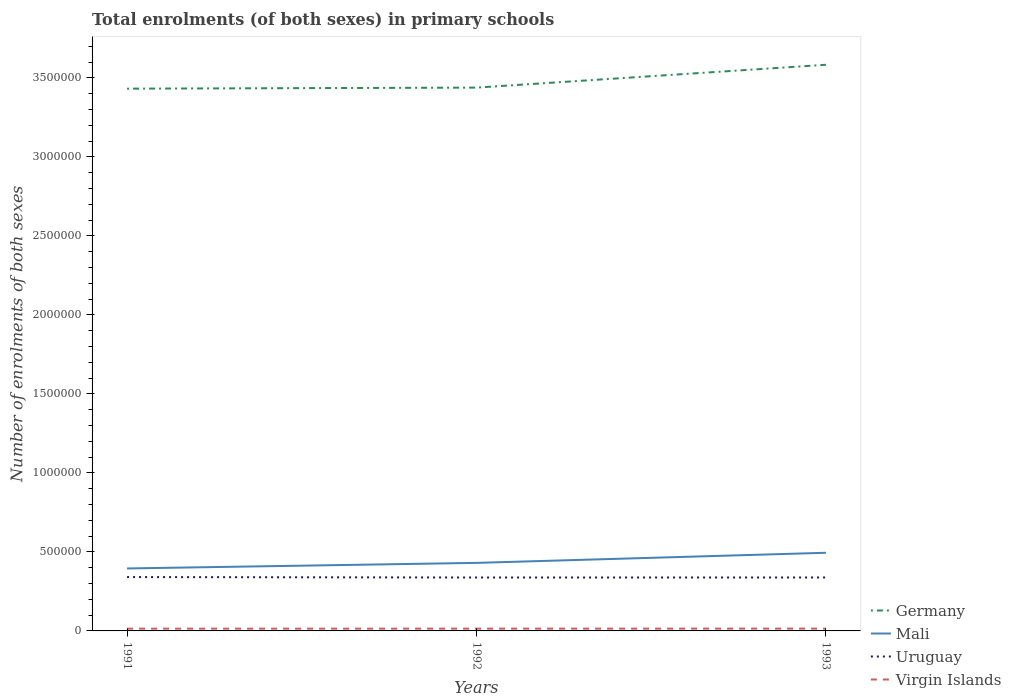Is the number of lines equal to the number of legend labels?
Offer a terse response. Yes. Across all years, what is the maximum number of enrolments in primary schools in Mali?
Give a very brief answer. 3.95e+05. In which year was the number of enrolments in primary schools in Germany maximum?
Offer a very short reply. 1991. What is the total number of enrolments in primary schools in Mali in the graph?
Give a very brief answer. -9.92e+04. What is the difference between the highest and the second highest number of enrolments in primary schools in Germany?
Ensure brevity in your answer.  1.51e+05. Is the number of enrolments in primary schools in Virgin Islands strictly greater than the number of enrolments in primary schools in Germany over the years?
Offer a terse response. Yes. How many lines are there?
Offer a terse response. 4. How many years are there in the graph?
Ensure brevity in your answer.  3. Does the graph contain any zero values?
Offer a very short reply. No. What is the title of the graph?
Your answer should be compact. Total enrolments (of both sexes) in primary schools. What is the label or title of the X-axis?
Provide a short and direct response. Years. What is the label or title of the Y-axis?
Offer a very short reply. Number of enrolments of both sexes. What is the Number of enrolments of both sexes in Germany in 1991?
Your response must be concise. 3.43e+06. What is the Number of enrolments of both sexes in Mali in 1991?
Your response must be concise. 3.95e+05. What is the Number of enrolments of both sexes of Uruguay in 1991?
Make the answer very short. 3.41e+05. What is the Number of enrolments of both sexes of Virgin Islands in 1991?
Offer a very short reply. 1.43e+04. What is the Number of enrolments of both sexes in Germany in 1992?
Offer a very short reply. 3.44e+06. What is the Number of enrolments of both sexes of Mali in 1992?
Give a very brief answer. 4.31e+05. What is the Number of enrolments of both sexes of Uruguay in 1992?
Keep it short and to the point. 3.38e+05. What is the Number of enrolments of both sexes of Virgin Islands in 1992?
Make the answer very short. 1.44e+04. What is the Number of enrolments of both sexes in Germany in 1993?
Ensure brevity in your answer.  3.58e+06. What is the Number of enrolments of both sexes in Mali in 1993?
Your answer should be very brief. 4.95e+05. What is the Number of enrolments of both sexes in Uruguay in 1993?
Give a very brief answer. 3.38e+05. What is the Number of enrolments of both sexes of Virgin Islands in 1993?
Make the answer very short. 1.45e+04. Across all years, what is the maximum Number of enrolments of both sexes of Germany?
Make the answer very short. 3.58e+06. Across all years, what is the maximum Number of enrolments of both sexes in Mali?
Your answer should be very brief. 4.95e+05. Across all years, what is the maximum Number of enrolments of both sexes of Uruguay?
Ensure brevity in your answer.  3.41e+05. Across all years, what is the maximum Number of enrolments of both sexes of Virgin Islands?
Your answer should be compact. 1.45e+04. Across all years, what is the minimum Number of enrolments of both sexes of Germany?
Offer a very short reply. 3.43e+06. Across all years, what is the minimum Number of enrolments of both sexes in Mali?
Your answer should be very brief. 3.95e+05. Across all years, what is the minimum Number of enrolments of both sexes of Uruguay?
Keep it short and to the point. 3.38e+05. Across all years, what is the minimum Number of enrolments of both sexes in Virgin Islands?
Offer a terse response. 1.43e+04. What is the total Number of enrolments of both sexes of Germany in the graph?
Make the answer very short. 1.05e+07. What is the total Number of enrolments of both sexes in Mali in the graph?
Offer a very short reply. 1.32e+06. What is the total Number of enrolments of both sexes of Uruguay in the graph?
Offer a terse response. 1.02e+06. What is the total Number of enrolments of both sexes in Virgin Islands in the graph?
Keep it short and to the point. 4.33e+04. What is the difference between the Number of enrolments of both sexes in Germany in 1991 and that in 1992?
Your answer should be compact. -6667. What is the difference between the Number of enrolments of both sexes of Mali in 1991 and that in 1992?
Provide a succinct answer. -3.53e+04. What is the difference between the Number of enrolments of both sexes of Uruguay in 1991 and that in 1992?
Provide a succinct answer. 2769. What is the difference between the Number of enrolments of both sexes in Virgin Islands in 1991 and that in 1992?
Keep it short and to the point. -81. What is the difference between the Number of enrolments of both sexes in Germany in 1991 and that in 1993?
Your response must be concise. -1.51e+05. What is the difference between the Number of enrolments of both sexes in Mali in 1991 and that in 1993?
Keep it short and to the point. -9.92e+04. What is the difference between the Number of enrolments of both sexes in Uruguay in 1991 and that in 1993?
Provide a succinct answer. 2585. What is the difference between the Number of enrolments of both sexes in Virgin Islands in 1991 and that in 1993?
Offer a terse response. -225. What is the difference between the Number of enrolments of both sexes of Germany in 1992 and that in 1993?
Your response must be concise. -1.45e+05. What is the difference between the Number of enrolments of both sexes in Mali in 1992 and that in 1993?
Keep it short and to the point. -6.39e+04. What is the difference between the Number of enrolments of both sexes of Uruguay in 1992 and that in 1993?
Offer a terse response. -184. What is the difference between the Number of enrolments of both sexes in Virgin Islands in 1992 and that in 1993?
Offer a very short reply. -144. What is the difference between the Number of enrolments of both sexes in Germany in 1991 and the Number of enrolments of both sexes in Mali in 1992?
Give a very brief answer. 3.00e+06. What is the difference between the Number of enrolments of both sexes in Germany in 1991 and the Number of enrolments of both sexes in Uruguay in 1992?
Your answer should be compact. 3.09e+06. What is the difference between the Number of enrolments of both sexes of Germany in 1991 and the Number of enrolments of both sexes of Virgin Islands in 1992?
Keep it short and to the point. 3.42e+06. What is the difference between the Number of enrolments of both sexes in Mali in 1991 and the Number of enrolments of both sexes in Uruguay in 1992?
Offer a terse response. 5.73e+04. What is the difference between the Number of enrolments of both sexes in Mali in 1991 and the Number of enrolments of both sexes in Virgin Islands in 1992?
Make the answer very short. 3.81e+05. What is the difference between the Number of enrolments of both sexes of Uruguay in 1991 and the Number of enrolments of both sexes of Virgin Islands in 1992?
Provide a succinct answer. 3.26e+05. What is the difference between the Number of enrolments of both sexes of Germany in 1991 and the Number of enrolments of both sexes of Mali in 1993?
Provide a succinct answer. 2.94e+06. What is the difference between the Number of enrolments of both sexes of Germany in 1991 and the Number of enrolments of both sexes of Uruguay in 1993?
Your response must be concise. 3.09e+06. What is the difference between the Number of enrolments of both sexes in Germany in 1991 and the Number of enrolments of both sexes in Virgin Islands in 1993?
Provide a short and direct response. 3.42e+06. What is the difference between the Number of enrolments of both sexes of Mali in 1991 and the Number of enrolments of both sexes of Uruguay in 1993?
Provide a short and direct response. 5.71e+04. What is the difference between the Number of enrolments of both sexes in Mali in 1991 and the Number of enrolments of both sexes in Virgin Islands in 1993?
Provide a succinct answer. 3.81e+05. What is the difference between the Number of enrolments of both sexes in Uruguay in 1991 and the Number of enrolments of both sexes in Virgin Islands in 1993?
Your answer should be very brief. 3.26e+05. What is the difference between the Number of enrolments of both sexes in Germany in 1992 and the Number of enrolments of both sexes in Mali in 1993?
Provide a succinct answer. 2.94e+06. What is the difference between the Number of enrolments of both sexes in Germany in 1992 and the Number of enrolments of both sexes in Uruguay in 1993?
Offer a terse response. 3.10e+06. What is the difference between the Number of enrolments of both sexes in Germany in 1992 and the Number of enrolments of both sexes in Virgin Islands in 1993?
Your answer should be compact. 3.42e+06. What is the difference between the Number of enrolments of both sexes in Mali in 1992 and the Number of enrolments of both sexes in Uruguay in 1993?
Your response must be concise. 9.24e+04. What is the difference between the Number of enrolments of both sexes in Mali in 1992 and the Number of enrolments of both sexes in Virgin Islands in 1993?
Make the answer very short. 4.16e+05. What is the difference between the Number of enrolments of both sexes in Uruguay in 1992 and the Number of enrolments of both sexes in Virgin Islands in 1993?
Make the answer very short. 3.23e+05. What is the average Number of enrolments of both sexes of Germany per year?
Your answer should be compact. 3.48e+06. What is the average Number of enrolments of both sexes of Mali per year?
Make the answer very short. 4.40e+05. What is the average Number of enrolments of both sexes in Uruguay per year?
Your response must be concise. 3.39e+05. What is the average Number of enrolments of both sexes of Virgin Islands per year?
Ensure brevity in your answer.  1.44e+04. In the year 1991, what is the difference between the Number of enrolments of both sexes in Germany and Number of enrolments of both sexes in Mali?
Offer a very short reply. 3.04e+06. In the year 1991, what is the difference between the Number of enrolments of both sexes in Germany and Number of enrolments of both sexes in Uruguay?
Provide a succinct answer. 3.09e+06. In the year 1991, what is the difference between the Number of enrolments of both sexes in Germany and Number of enrolments of both sexes in Virgin Islands?
Keep it short and to the point. 3.42e+06. In the year 1991, what is the difference between the Number of enrolments of both sexes of Mali and Number of enrolments of both sexes of Uruguay?
Offer a terse response. 5.45e+04. In the year 1991, what is the difference between the Number of enrolments of both sexes in Mali and Number of enrolments of both sexes in Virgin Islands?
Offer a terse response. 3.81e+05. In the year 1991, what is the difference between the Number of enrolments of both sexes of Uruguay and Number of enrolments of both sexes of Virgin Islands?
Make the answer very short. 3.26e+05. In the year 1992, what is the difference between the Number of enrolments of both sexes in Germany and Number of enrolments of both sexes in Mali?
Give a very brief answer. 3.01e+06. In the year 1992, what is the difference between the Number of enrolments of both sexes in Germany and Number of enrolments of both sexes in Uruguay?
Offer a terse response. 3.10e+06. In the year 1992, what is the difference between the Number of enrolments of both sexes in Germany and Number of enrolments of both sexes in Virgin Islands?
Your response must be concise. 3.42e+06. In the year 1992, what is the difference between the Number of enrolments of both sexes of Mali and Number of enrolments of both sexes of Uruguay?
Your answer should be very brief. 9.26e+04. In the year 1992, what is the difference between the Number of enrolments of both sexes of Mali and Number of enrolments of both sexes of Virgin Islands?
Offer a very short reply. 4.16e+05. In the year 1992, what is the difference between the Number of enrolments of both sexes of Uruguay and Number of enrolments of both sexes of Virgin Islands?
Ensure brevity in your answer.  3.24e+05. In the year 1993, what is the difference between the Number of enrolments of both sexes of Germany and Number of enrolments of both sexes of Mali?
Your response must be concise. 3.09e+06. In the year 1993, what is the difference between the Number of enrolments of both sexes in Germany and Number of enrolments of both sexes in Uruguay?
Give a very brief answer. 3.24e+06. In the year 1993, what is the difference between the Number of enrolments of both sexes of Germany and Number of enrolments of both sexes of Virgin Islands?
Your answer should be compact. 3.57e+06. In the year 1993, what is the difference between the Number of enrolments of both sexes in Mali and Number of enrolments of both sexes in Uruguay?
Offer a terse response. 1.56e+05. In the year 1993, what is the difference between the Number of enrolments of both sexes in Mali and Number of enrolments of both sexes in Virgin Islands?
Offer a very short reply. 4.80e+05. In the year 1993, what is the difference between the Number of enrolments of both sexes of Uruguay and Number of enrolments of both sexes of Virgin Islands?
Keep it short and to the point. 3.24e+05. What is the ratio of the Number of enrolments of both sexes in Germany in 1991 to that in 1992?
Your answer should be very brief. 1. What is the ratio of the Number of enrolments of both sexes of Mali in 1991 to that in 1992?
Keep it short and to the point. 0.92. What is the ratio of the Number of enrolments of both sexes in Uruguay in 1991 to that in 1992?
Provide a short and direct response. 1.01. What is the ratio of the Number of enrolments of both sexes of Germany in 1991 to that in 1993?
Provide a succinct answer. 0.96. What is the ratio of the Number of enrolments of both sexes of Mali in 1991 to that in 1993?
Ensure brevity in your answer.  0.8. What is the ratio of the Number of enrolments of both sexes of Uruguay in 1991 to that in 1993?
Make the answer very short. 1.01. What is the ratio of the Number of enrolments of both sexes of Virgin Islands in 1991 to that in 1993?
Offer a very short reply. 0.98. What is the ratio of the Number of enrolments of both sexes in Germany in 1992 to that in 1993?
Your response must be concise. 0.96. What is the ratio of the Number of enrolments of both sexes of Mali in 1992 to that in 1993?
Your response must be concise. 0.87. What is the ratio of the Number of enrolments of both sexes of Uruguay in 1992 to that in 1993?
Give a very brief answer. 1. What is the difference between the highest and the second highest Number of enrolments of both sexes in Germany?
Give a very brief answer. 1.45e+05. What is the difference between the highest and the second highest Number of enrolments of both sexes of Mali?
Make the answer very short. 6.39e+04. What is the difference between the highest and the second highest Number of enrolments of both sexes in Uruguay?
Give a very brief answer. 2585. What is the difference between the highest and the second highest Number of enrolments of both sexes in Virgin Islands?
Provide a short and direct response. 144. What is the difference between the highest and the lowest Number of enrolments of both sexes in Germany?
Give a very brief answer. 1.51e+05. What is the difference between the highest and the lowest Number of enrolments of both sexes of Mali?
Your answer should be compact. 9.92e+04. What is the difference between the highest and the lowest Number of enrolments of both sexes in Uruguay?
Your answer should be very brief. 2769. What is the difference between the highest and the lowest Number of enrolments of both sexes in Virgin Islands?
Ensure brevity in your answer.  225. 